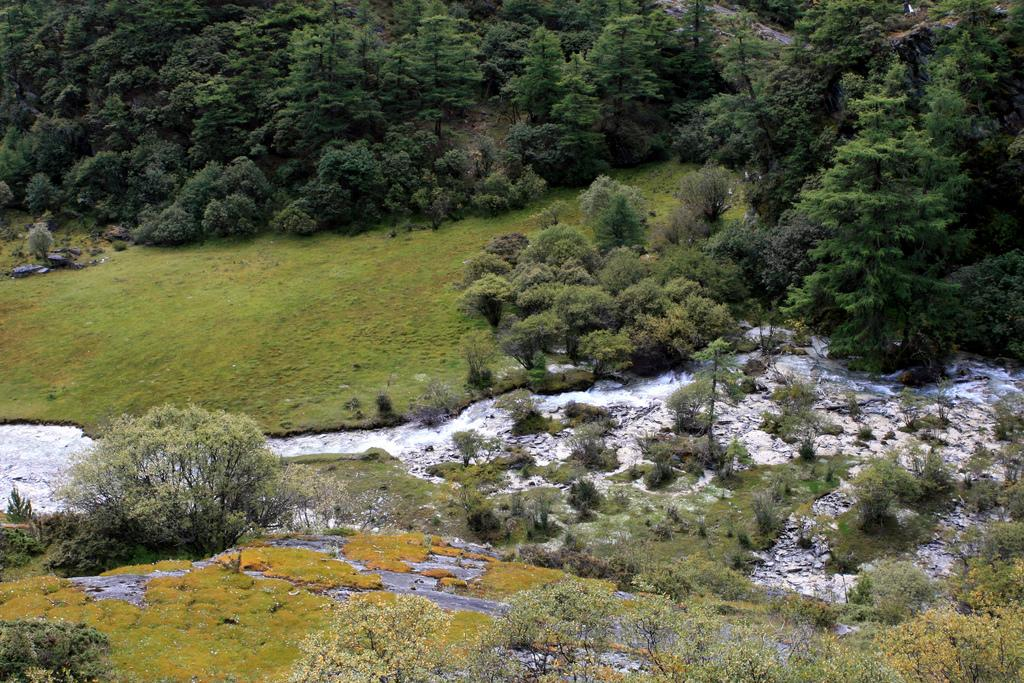What types of vegetation can be seen in the foreground of the image? There are bushes, plants, and grass in the foreground of the image. What is present in the foreground of the image besides vegetation? There is water in the foreground of the image. What types of vegetation can be seen in the background of the image? There are trees and grass in the background of the image. What else can be seen in the background of the image? There are stones in the background of the image. What type of society is depicted in the image? There is no society depicted in the image; it features natural elements such as vegetation, water, and stones. Can you tell me who the carpenter is in the image? There is no carpenter present in the image. 